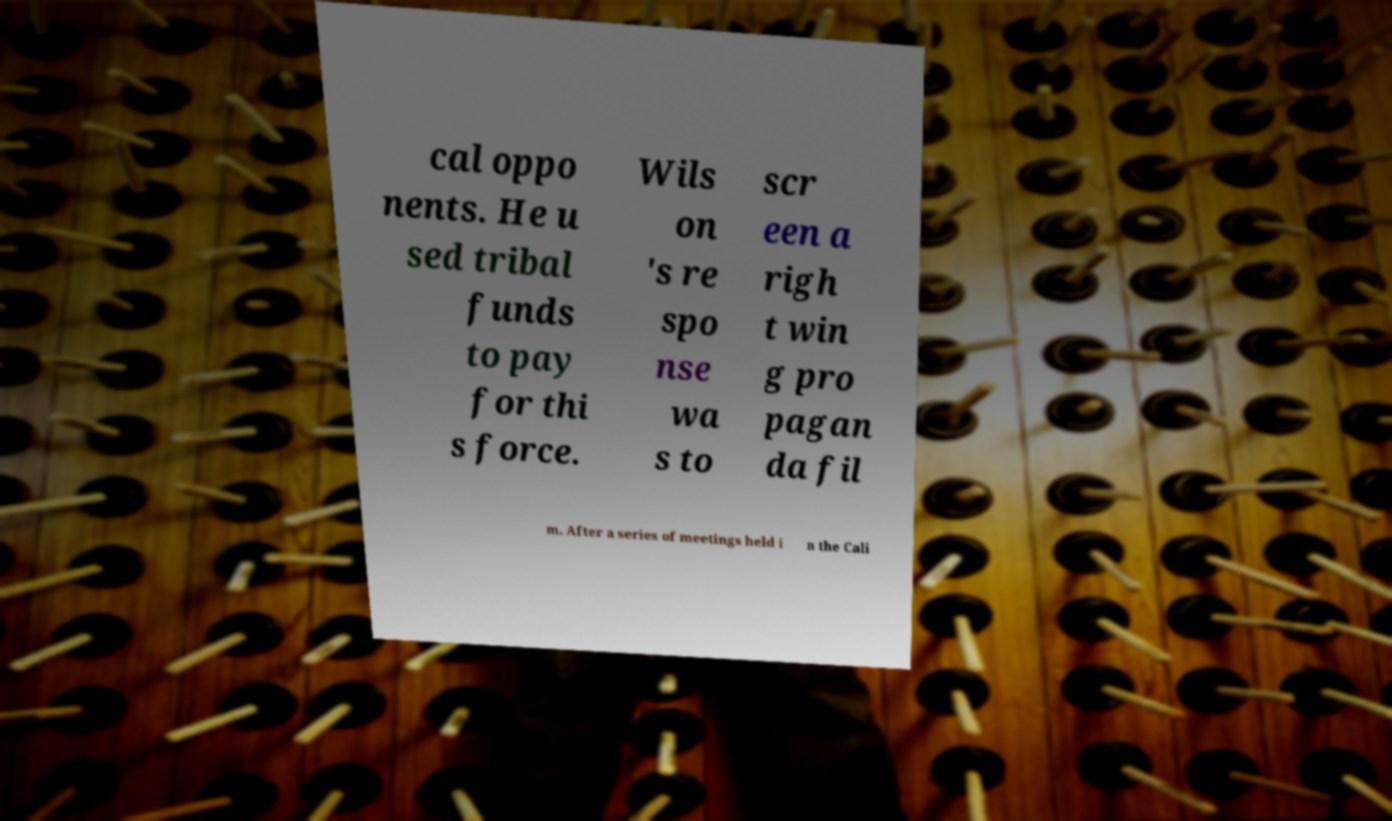Can you read and provide the text displayed in the image?This photo seems to have some interesting text. Can you extract and type it out for me? cal oppo nents. He u sed tribal funds to pay for thi s force. Wils on 's re spo nse wa s to scr een a righ t win g pro pagan da fil m. After a series of meetings held i n the Cali 